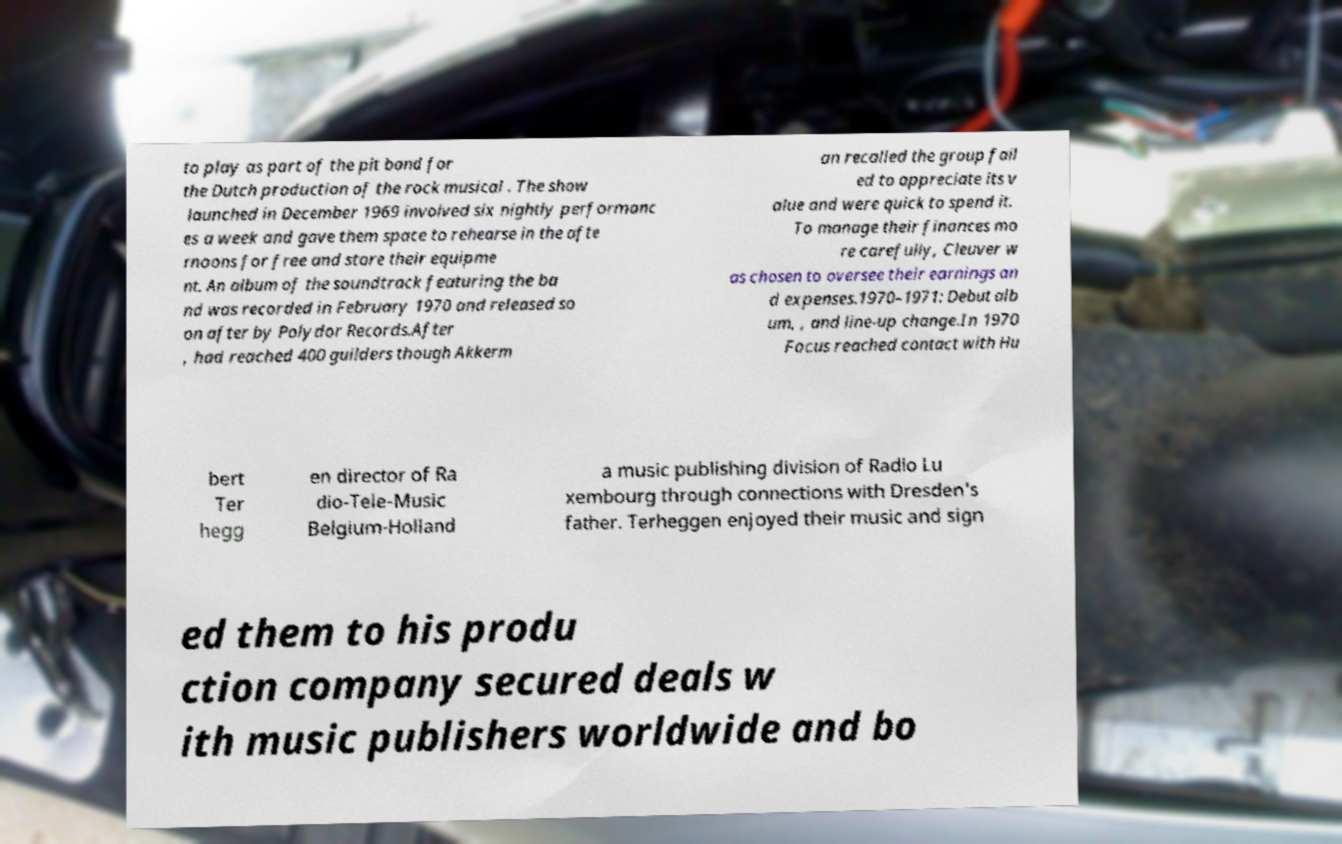I need the written content from this picture converted into text. Can you do that? to play as part of the pit band for the Dutch production of the rock musical . The show launched in December 1969 involved six nightly performanc es a week and gave them space to rehearse in the afte rnoons for free and store their equipme nt. An album of the soundtrack featuring the ba nd was recorded in February 1970 and released so on after by Polydor Records.After , had reached 400 guilders though Akkerm an recalled the group fail ed to appreciate its v alue and were quick to spend it. To manage their finances mo re carefully, Cleuver w as chosen to oversee their earnings an d expenses.1970–1971: Debut alb um, , and line-up change.In 1970 Focus reached contact with Hu bert Ter hegg en director of Ra dio-Tele-Music Belgium-Holland a music publishing division of Radio Lu xembourg through connections with Dresden's father. Terheggen enjoyed their music and sign ed them to his produ ction company secured deals w ith music publishers worldwide and bo 